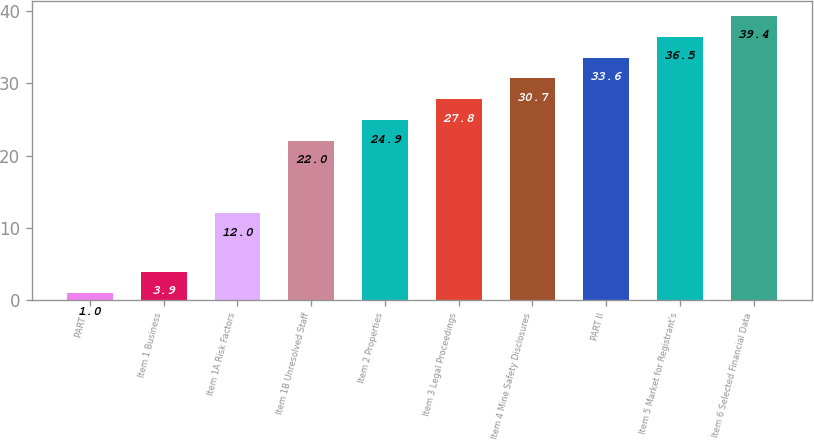<chart> <loc_0><loc_0><loc_500><loc_500><bar_chart><fcel>PART I<fcel>Item 1 Business<fcel>Item 1A Risk Factors<fcel>Item 1B Unresolved Staff<fcel>Item 2 Properties<fcel>Item 3 Legal Proceedings<fcel>Item 4 Mine Safety Disclosures<fcel>PART II<fcel>Item 5 Market for Registrant's<fcel>Item 6 Selected Financial Data<nl><fcel>1<fcel>3.9<fcel>12<fcel>22<fcel>24.9<fcel>27.8<fcel>30.7<fcel>33.6<fcel>36.5<fcel>39.4<nl></chart> 